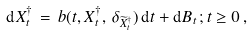<formula> <loc_0><loc_0><loc_500><loc_500>{ \mathrm d } X ^ { \dagger } _ { t } \, = \, b ( t , X _ { t } ^ { \dagger } , \, \delta _ { \widetilde { X } _ { t } ^ { \dagger } } ) \, { \mathrm d } t + { \mathrm d } B _ { t } \, ; t \geq 0 \, ,</formula> 